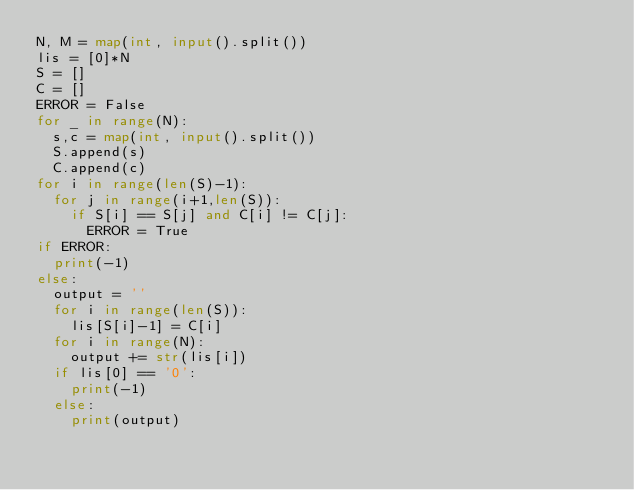Convert code to text. <code><loc_0><loc_0><loc_500><loc_500><_Python_>N, M = map(int, input().split())
lis = [0]*N
S = []
C = []
ERROR = False
for _ in range(N):
  s,c = map(int, input().split())
  S.append(s)
  C.append(c)
for i in range(len(S)-1):
  for j in range(i+1,len(S)):
    if S[i] == S[j] and C[i] != C[j]:
      ERROR = True
if ERROR:
  print(-1)
else:
  output = ''
  for i in range(len(S)):
    lis[S[i]-1] = C[i]
  for i in range(N):
    output += str(lis[i])
  if lis[0] == '0':
    print(-1)
  else:
    print(output)</code> 